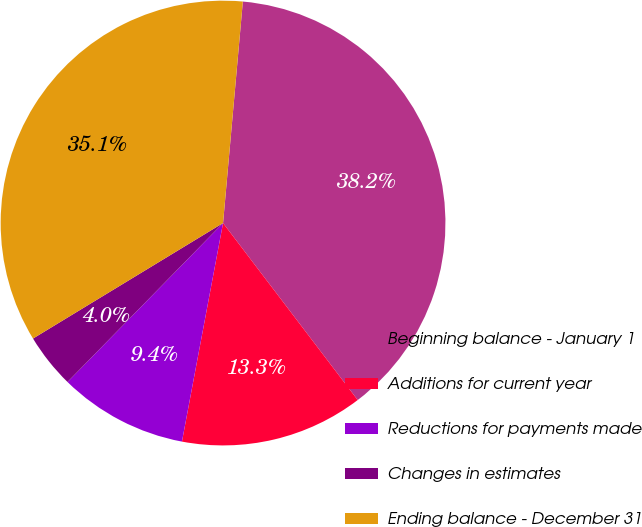Convert chart. <chart><loc_0><loc_0><loc_500><loc_500><pie_chart><fcel>Beginning balance - January 1<fcel>Additions for current year<fcel>Reductions for payments made<fcel>Changes in estimates<fcel>Ending balance - December 31<nl><fcel>38.23%<fcel>13.31%<fcel>9.37%<fcel>3.98%<fcel>35.11%<nl></chart> 